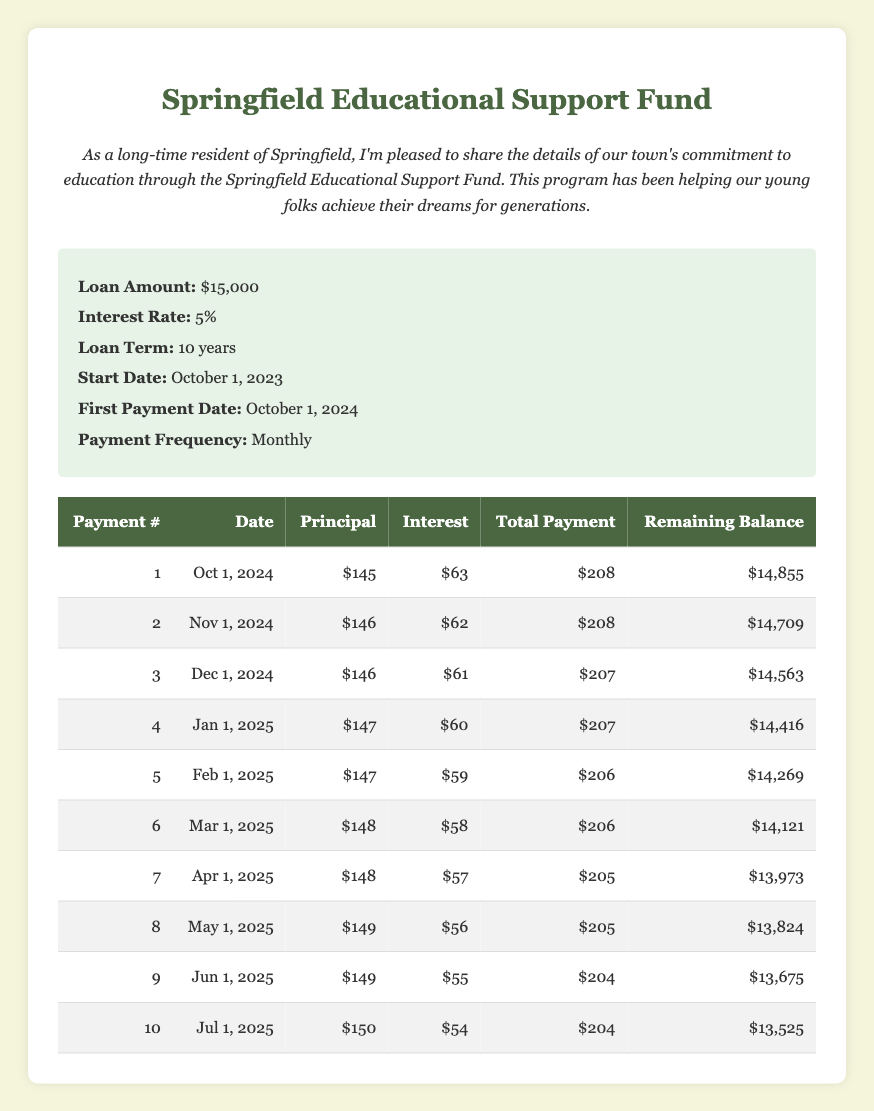What is the total payment for the first installment? The first installment's total payment is clearly stated in the table under the "Total Payment" column for payment number 1, which shows $208.
Answer: 208 How much was paid towards the principal in the second payment? Looking at the second payment row in the table, the "Principal" column shows that $146 was paid towards the principal for payment number 2.
Answer: 146 What is the remaining balance after the third payment? In the row for the third payment, the "Remaining Balance" column indicates that the remaining balance after this payment is $14,563.
Answer: 14563 What is the total amount paid towards interest after the first four payments? To find the total interest paid after the first four payments, we must add the interest payments from the first four rows: $63 + $62 + $61 + $60 = $246.
Answer: 246 Did the interest payment decrease for the first ten installments? By examining the "Interest" column for each of the first ten payments, we see that the interest payments decrease consistently from $63 down to $54, confirming that the interest payments did decrease over this span.
Answer: Yes How much total principal was paid in the first five payments? Calculating the total principal paid in the first five payments involves summing the principal amounts from each of the first five rows: $145 + $146 + $146 + $147 + $147 = $731.
Answer: 731 What was the average total payment over the first ten payments? To calculate the average total payment, first sum the total payments from all ten rows: $208 + $208 + $207 + $207 + $206 + $206 + $205 + $205 + $204 + $204 = $2,066. Then, divide by 10 (the number of payments) to get the average: $2,066 / 10 = $206.6.
Answer: 206.6 Is the principal payment for the eighth installment greater than that for the fifth installment? Comparing the "Principal" column values, the eighth installment shows $149 while the fifth shows $147, confirming that the principal payment for the eighth installment is greater.
Answer: Yes What is the difference in total payment between the first and last installment? To determine this, subtract the total payment for the last installment ($204) from the total payment for the first installment ($208): $208 - $204 = $4.
Answer: 4 